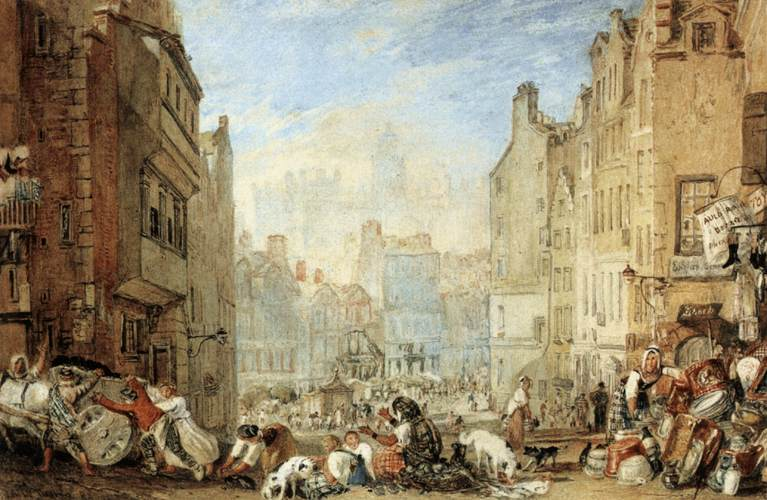Imagine the sounds and smells of this street scene. What would they be like? The street would be filled with a cacophony of sounds: the chatter of people haggling, the clatter of horses' hooves, the creak of wooden cartwheels, and the occasional bark of dogs. You might hear street vendors calling out to potential buyers, the laughter of children, and the din of everyday city life. The smells would be equally vivid: the fresh scent of baked bread, the earthy aroma of fruits and vegetables, the pungent whiff of livestock, and perhaps the occasional waft of smoke from nearby chimneys. Can you give a detailed description of one of the buildings in the background? Sure! Focus on a prominent building in the background. This building is several stories high, displaying a weathered facade of stone or brick. Its architectural design includes a series of arched windows, some with intricate ironwork or wooden shutters. The roof is steeply pitched, possibly covered with terracotta tiles. Signs hang from its walls, possibly indicating businesses or taverns, contributing to the vibrant marketplace atmosphere. The building’s stonework suggests it has withstood the test of time, adding a timeless character to the overall scene. 